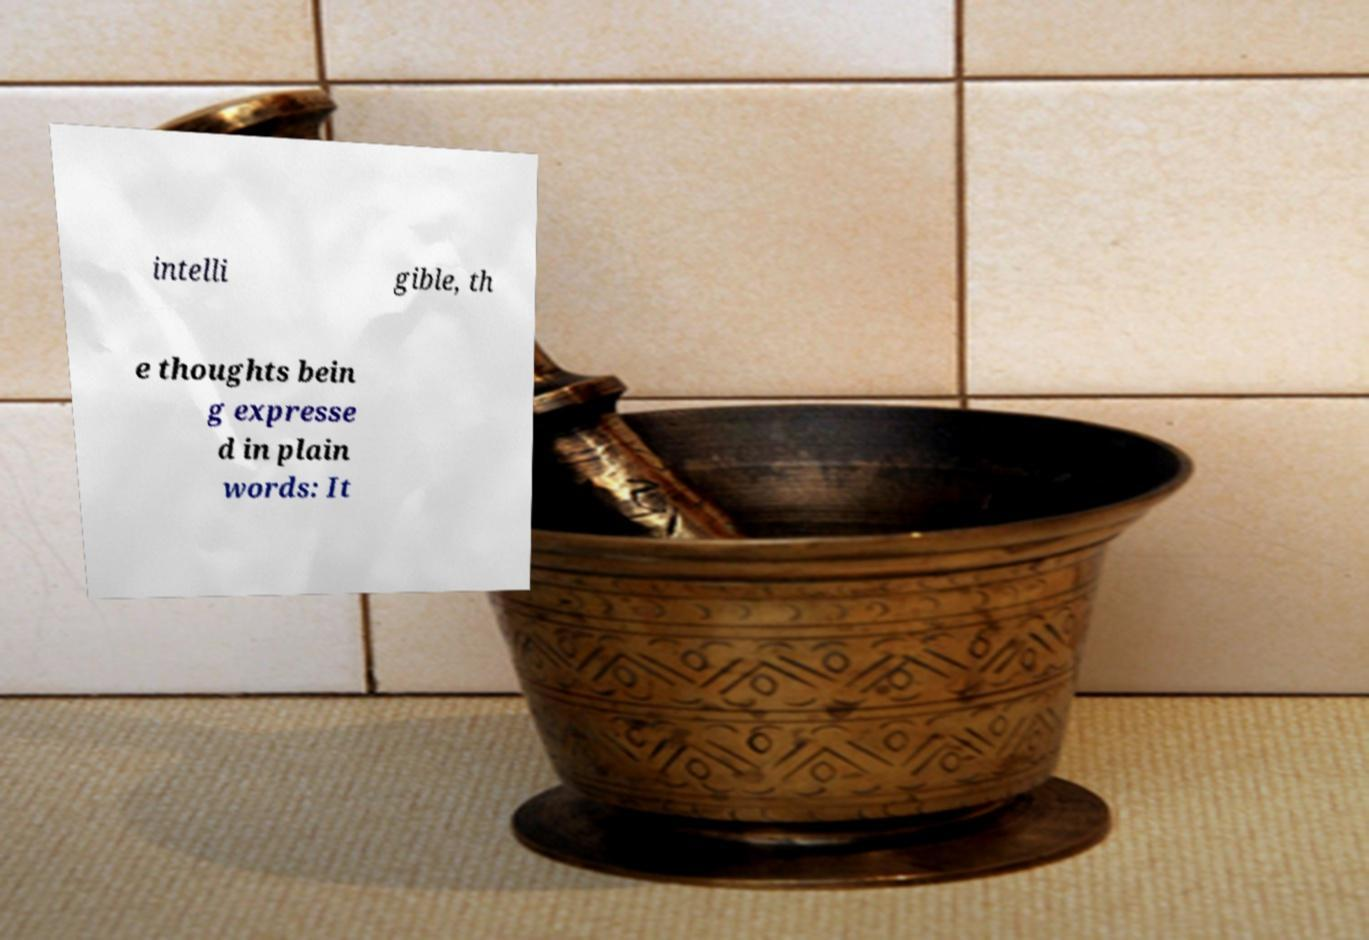There's text embedded in this image that I need extracted. Can you transcribe it verbatim? intelli gible, th e thoughts bein g expresse d in plain words: It 